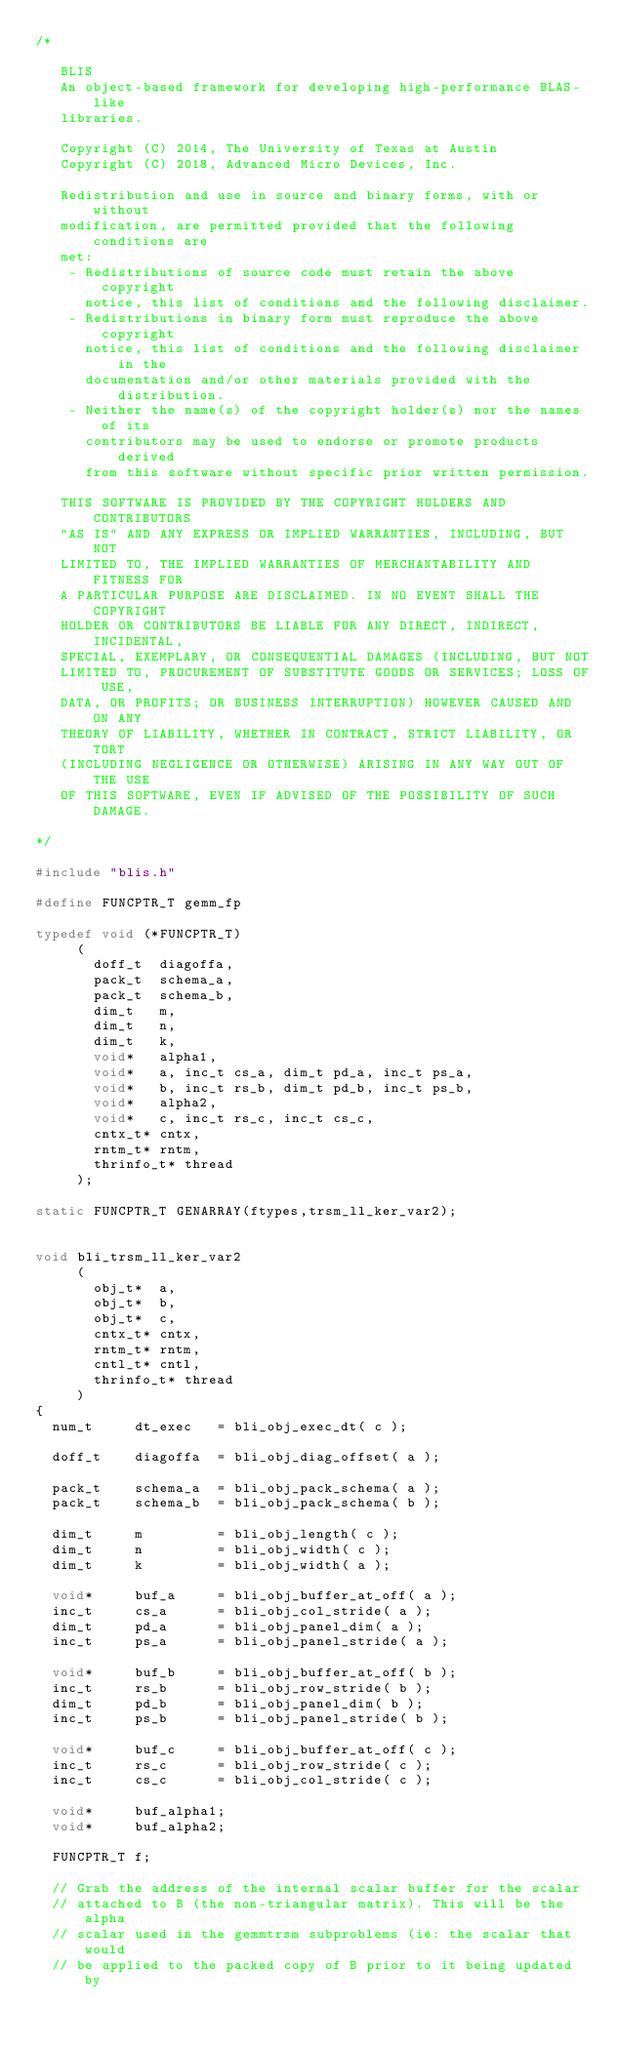Convert code to text. <code><loc_0><loc_0><loc_500><loc_500><_C_>/*

   BLIS
   An object-based framework for developing high-performance BLAS-like
   libraries.

   Copyright (C) 2014, The University of Texas at Austin
   Copyright (C) 2018, Advanced Micro Devices, Inc.

   Redistribution and use in source and binary forms, with or without
   modification, are permitted provided that the following conditions are
   met:
    - Redistributions of source code must retain the above copyright
      notice, this list of conditions and the following disclaimer.
    - Redistributions in binary form must reproduce the above copyright
      notice, this list of conditions and the following disclaimer in the
      documentation and/or other materials provided with the distribution.
    - Neither the name(s) of the copyright holder(s) nor the names of its
      contributors may be used to endorse or promote products derived
      from this software without specific prior written permission.

   THIS SOFTWARE IS PROVIDED BY THE COPYRIGHT HOLDERS AND CONTRIBUTORS
   "AS IS" AND ANY EXPRESS OR IMPLIED WARRANTIES, INCLUDING, BUT NOT
   LIMITED TO, THE IMPLIED WARRANTIES OF MERCHANTABILITY AND FITNESS FOR
   A PARTICULAR PURPOSE ARE DISCLAIMED. IN NO EVENT SHALL THE COPYRIGHT
   HOLDER OR CONTRIBUTORS BE LIABLE FOR ANY DIRECT, INDIRECT, INCIDENTAL,
   SPECIAL, EXEMPLARY, OR CONSEQUENTIAL DAMAGES (INCLUDING, BUT NOT
   LIMITED TO, PROCUREMENT OF SUBSTITUTE GOODS OR SERVICES; LOSS OF USE,
   DATA, OR PROFITS; OR BUSINESS INTERRUPTION) HOWEVER CAUSED AND ON ANY
   THEORY OF LIABILITY, WHETHER IN CONTRACT, STRICT LIABILITY, OR TORT
   (INCLUDING NEGLIGENCE OR OTHERWISE) ARISING IN ANY WAY OUT OF THE USE
   OF THIS SOFTWARE, EVEN IF ADVISED OF THE POSSIBILITY OF SUCH DAMAGE.

*/

#include "blis.h"

#define FUNCPTR_T gemm_fp

typedef void (*FUNCPTR_T)
     (
       doff_t  diagoffa,
       pack_t  schema_a,
       pack_t  schema_b,
       dim_t   m,
       dim_t   n,
       dim_t   k,
       void*   alpha1,
       void*   a, inc_t cs_a, dim_t pd_a, inc_t ps_a,
       void*   b, inc_t rs_b, dim_t pd_b, inc_t ps_b,
       void*   alpha2,
       void*   c, inc_t rs_c, inc_t cs_c,
       cntx_t* cntx,
       rntm_t* rntm,
       thrinfo_t* thread
     );

static FUNCPTR_T GENARRAY(ftypes,trsm_ll_ker_var2);


void bli_trsm_ll_ker_var2
     (
       obj_t*  a,
       obj_t*  b,
       obj_t*  c,
       cntx_t* cntx,
       rntm_t* rntm,
       cntl_t* cntl,
       thrinfo_t* thread
     )
{
	num_t     dt_exec   = bli_obj_exec_dt( c );

	doff_t    diagoffa  = bli_obj_diag_offset( a );

	pack_t    schema_a  = bli_obj_pack_schema( a );
	pack_t    schema_b  = bli_obj_pack_schema( b );

	dim_t     m         = bli_obj_length( c );
	dim_t     n         = bli_obj_width( c );
	dim_t     k         = bli_obj_width( a );

	void*     buf_a     = bli_obj_buffer_at_off( a );
	inc_t     cs_a      = bli_obj_col_stride( a );
	dim_t     pd_a      = bli_obj_panel_dim( a );
	inc_t     ps_a      = bli_obj_panel_stride( a );

	void*     buf_b     = bli_obj_buffer_at_off( b );
	inc_t     rs_b      = bli_obj_row_stride( b );
	dim_t     pd_b      = bli_obj_panel_dim( b );
	inc_t     ps_b      = bli_obj_panel_stride( b );

	void*     buf_c     = bli_obj_buffer_at_off( c );
	inc_t     rs_c      = bli_obj_row_stride( c );
	inc_t     cs_c      = bli_obj_col_stride( c );

	void*     buf_alpha1;
	void*     buf_alpha2;

	FUNCPTR_T f;

	// Grab the address of the internal scalar buffer for the scalar
	// attached to B (the non-triangular matrix). This will be the alpha
	// scalar used in the gemmtrsm subproblems (ie: the scalar that would
	// be applied to the packed copy of B prior to it being updated by</code> 